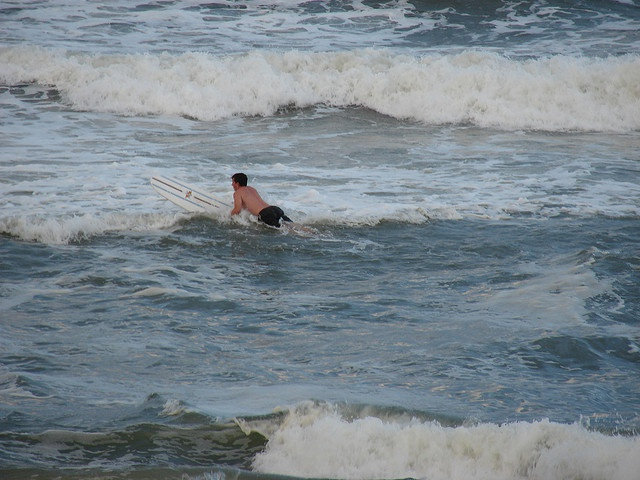Describe the objects in this image and their specific colors. I can see people in gray, brown, black, and darkgray tones and surfboard in gray, darkgray, and lightgray tones in this image. 